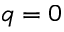<formula> <loc_0><loc_0><loc_500><loc_500>q = 0</formula> 